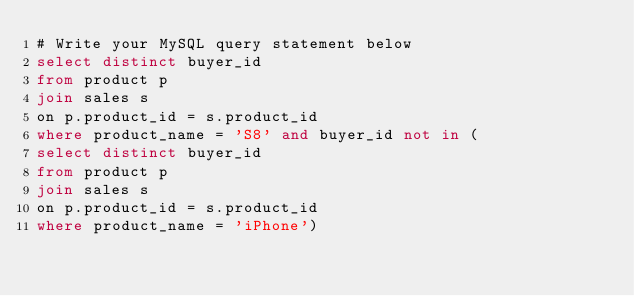Convert code to text. <code><loc_0><loc_0><loc_500><loc_500><_SQL_># Write your MySQL query statement below
select distinct buyer_id
from product p
join sales s
on p.product_id = s.product_id
where product_name = 'S8' and buyer_id not in (
select distinct buyer_id
from product p
join sales s
on p.product_id = s.product_id
where product_name = 'iPhone')</code> 